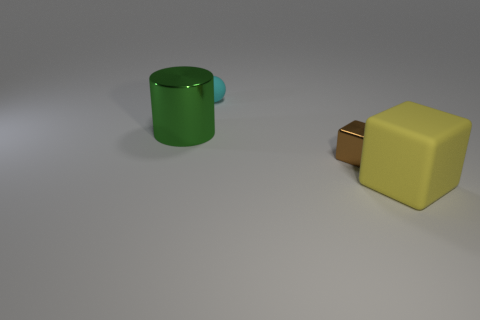How many tiny objects are red matte things or yellow things?
Your response must be concise. 0. Are there more small cyan matte spheres in front of the tiny rubber sphere than green shiny cylinders that are on the right side of the large green thing?
Give a very brief answer. No. What number of other things are there of the same size as the cyan thing?
Make the answer very short. 1. Is the material of the block that is behind the large yellow matte cube the same as the large green cylinder?
Offer a very short reply. Yes. How many other things are the same color as the matte cube?
Provide a succinct answer. 0. What number of other things are there of the same shape as the green metallic thing?
Your response must be concise. 0. Is the shape of the rubber object that is left of the yellow object the same as the tiny thing that is in front of the tiny cyan rubber object?
Give a very brief answer. No. Is the number of yellow rubber objects in front of the small brown block the same as the number of small rubber spheres behind the big matte block?
Your answer should be compact. Yes. There is a metal thing to the right of the large object that is behind the large thing that is in front of the metal cylinder; what shape is it?
Give a very brief answer. Cube. Do the big object that is to the right of the big metal object and the cyan ball that is behind the big yellow thing have the same material?
Your response must be concise. Yes. 